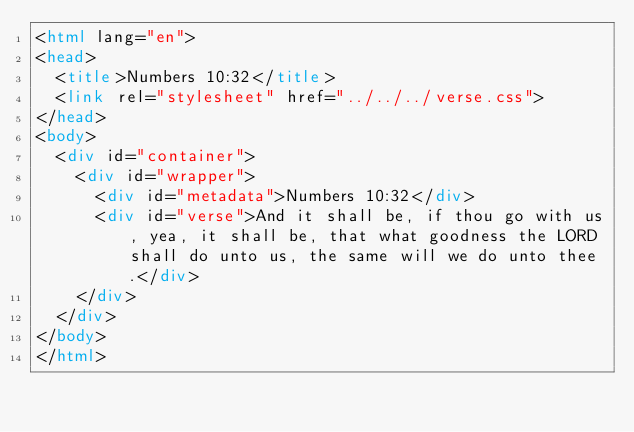Convert code to text. <code><loc_0><loc_0><loc_500><loc_500><_HTML_><html lang="en">
<head>
  <title>Numbers 10:32</title>
  <link rel="stylesheet" href="../../../verse.css">
</head>
<body>
  <div id="container">
    <div id="wrapper">
      <div id="metadata">Numbers 10:32</div>
      <div id="verse">And it shall be, if thou go with us, yea, it shall be, that what goodness the LORD shall do unto us, the same will we do unto thee.</div>
    </div>
  </div>
</body>
</html></code> 